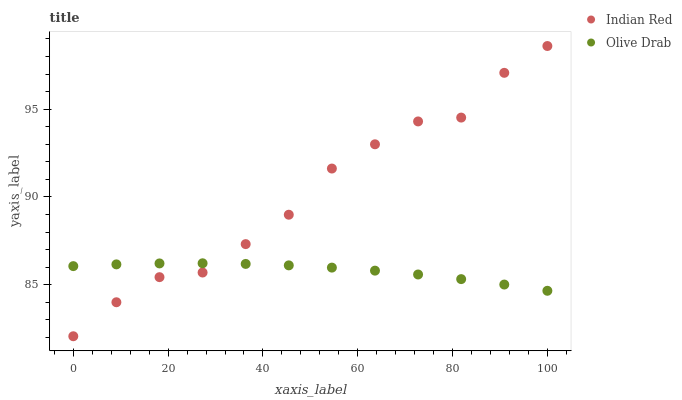Does Olive Drab have the minimum area under the curve?
Answer yes or no. Yes. Does Indian Red have the maximum area under the curve?
Answer yes or no. Yes. Does Indian Red have the minimum area under the curve?
Answer yes or no. No. Is Olive Drab the smoothest?
Answer yes or no. Yes. Is Indian Red the roughest?
Answer yes or no. Yes. Is Indian Red the smoothest?
Answer yes or no. No. Does Indian Red have the lowest value?
Answer yes or no. Yes. Does Indian Red have the highest value?
Answer yes or no. Yes. Does Olive Drab intersect Indian Red?
Answer yes or no. Yes. Is Olive Drab less than Indian Red?
Answer yes or no. No. Is Olive Drab greater than Indian Red?
Answer yes or no. No. 